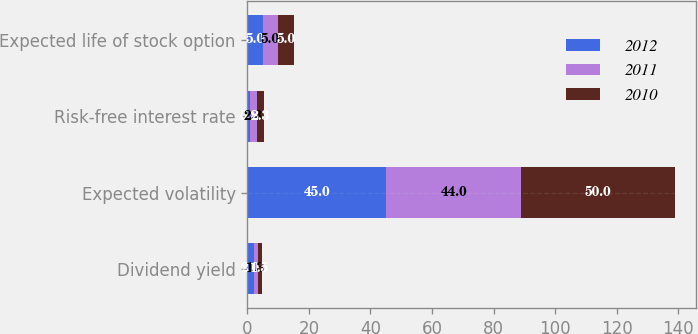<chart> <loc_0><loc_0><loc_500><loc_500><stacked_bar_chart><ecel><fcel>Dividend yield<fcel>Expected volatility<fcel>Risk-free interest rate<fcel>Expected life of stock option<nl><fcel>2012<fcel>2<fcel>45<fcel>0.8<fcel>5<nl><fcel>2011<fcel>1.3<fcel>44<fcel>2.3<fcel>5<nl><fcel>2010<fcel>1.5<fcel>50<fcel>2.3<fcel>5<nl></chart> 